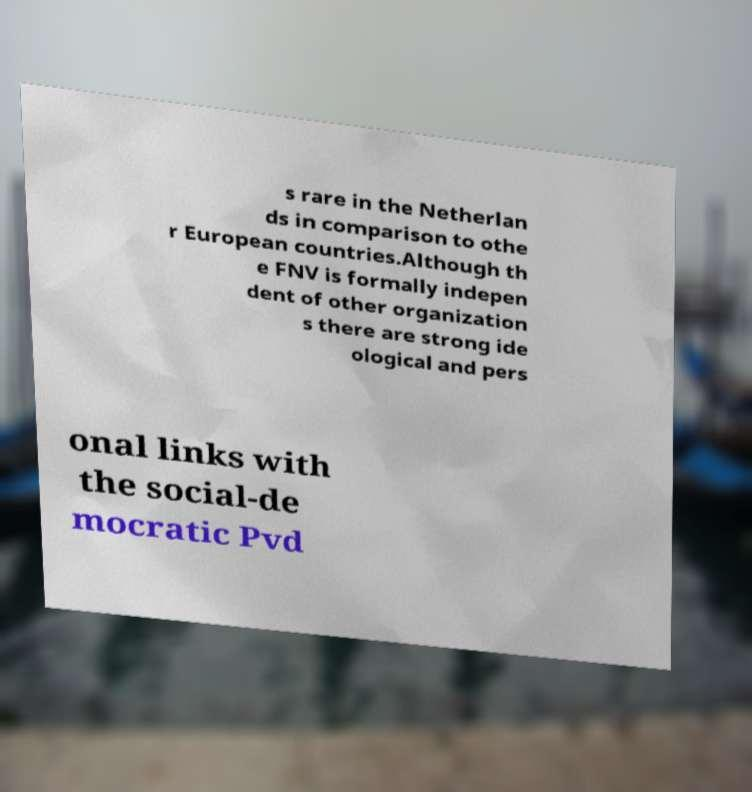Can you accurately transcribe the text from the provided image for me? s rare in the Netherlan ds in comparison to othe r European countries.Although th e FNV is formally indepen dent of other organization s there are strong ide ological and pers onal links with the social-de mocratic Pvd 